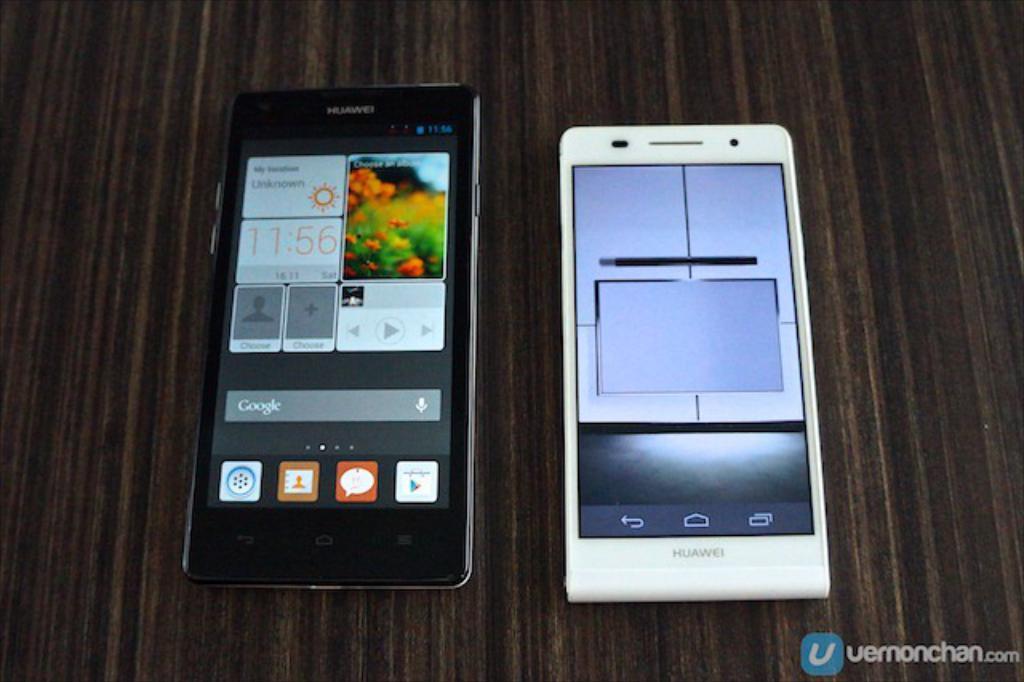<image>
Render a clear and concise summary of the photo. Two cell phones sitting next to one another and one has flowers and the time 11:56 on the screen. 